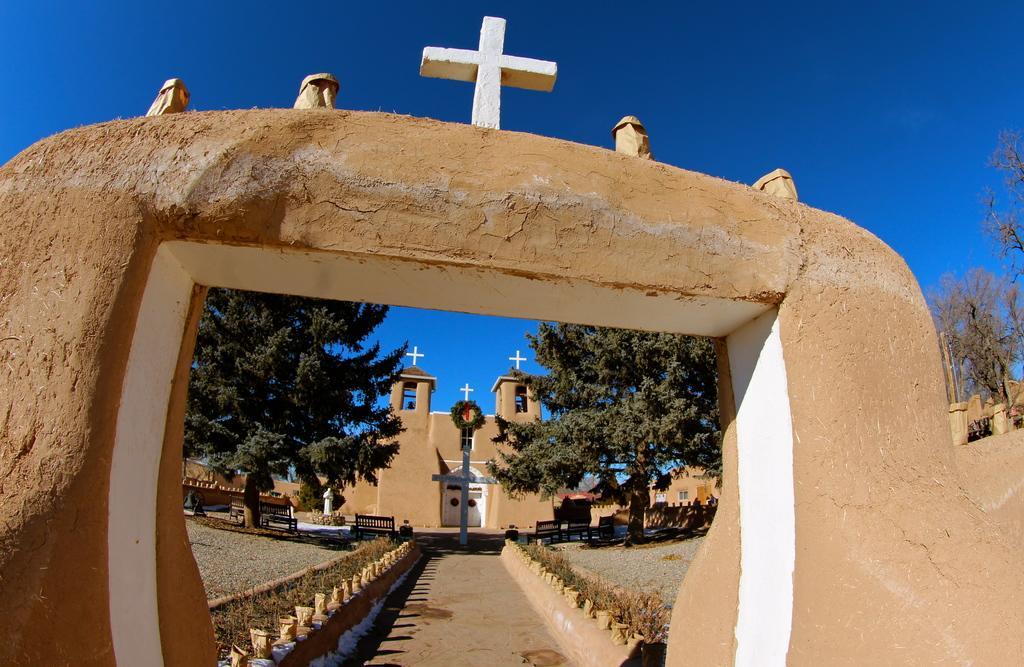Could you give a brief overview of what you see in this image? In front of the picture, we see an arch. At the bottom, we see the pavement. On either side of the pavement, we see the grass. On the right side, we see the trees. There are trees, benches, a statue, crucifix and a church in the background. At the top, we see the sky, which is blue in color. 